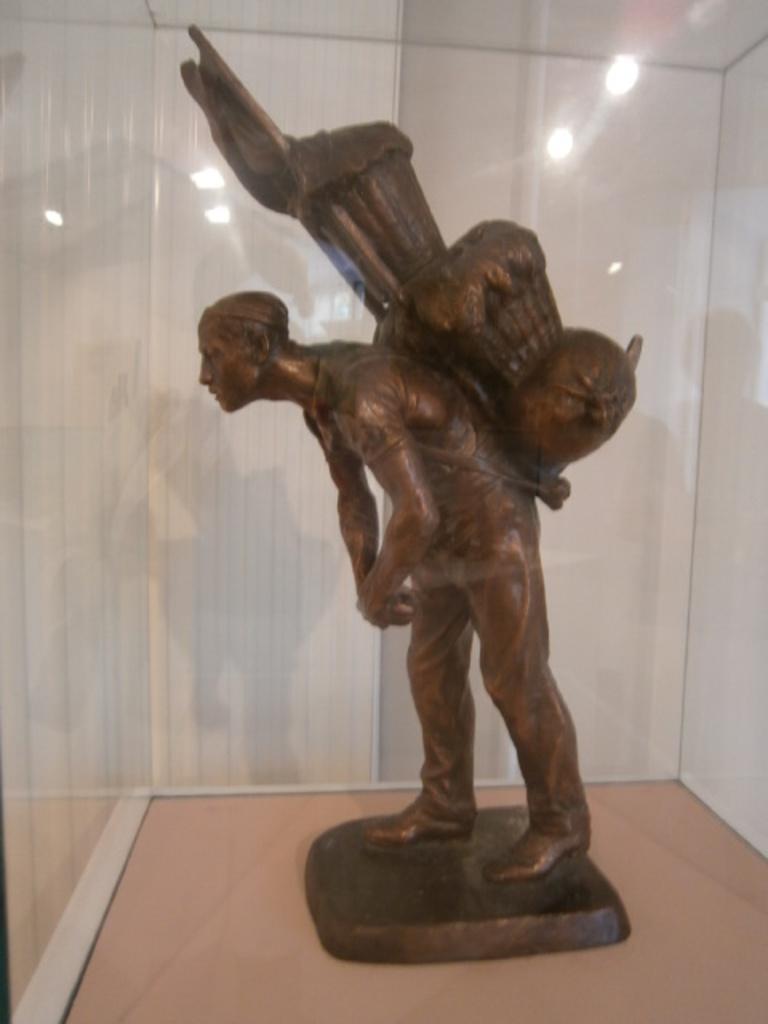Please provide a concise description of this image. In this image I see the sculpture of a person and I see that the sculpture is of brown in color and it is on the cream color surface and in the background I see the white wall and I see the reflection of the lights. 